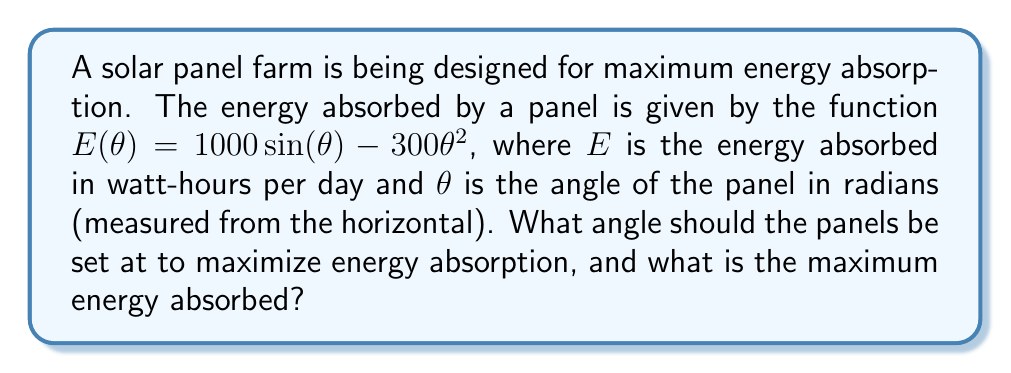Give your solution to this math problem. To find the optimal angle for maximum energy absorption, we need to find the maximum of the function $E(\theta)$. This can be done by finding where the derivative of $E(\theta)$ equals zero.

1) First, let's find the derivative of $E(\theta)$:

   $$\frac{dE}{d\theta} = 1000 \cos(\theta) - 600\theta$$

2) Now, set this equal to zero and solve for $\theta$:

   $$1000 \cos(\theta) - 600\theta = 0$$

3) This equation can't be solved algebraically, so we need to use numerical methods. Using a graphing calculator or computer software, we can find that this equation is satisfied when:

   $$\theta \approx 0.5969 \text{ radians}$$

4) To confirm this is a maximum (not a minimum), we can check the second derivative:

   $$\frac{d^2E}{d\theta^2} = -1000 \sin(\theta) - 600$$

   At $\theta = 0.5969$, this is negative, confirming a maximum.

5) To find the maximum energy absorbed, we plug this value of $\theta$ back into our original function:

   $$E(0.5969) = 1000 \sin(0.5969) - 300(0.5969)^2 \approx 462.77 \text{ watt-hours per day}$$
Answer: The optimal angle for the solar panels is approximately 0.5969 radians (or about 34.2 degrees) from the horizontal. At this angle, the maximum energy absorbed is approximately 462.77 watt-hours per day. 